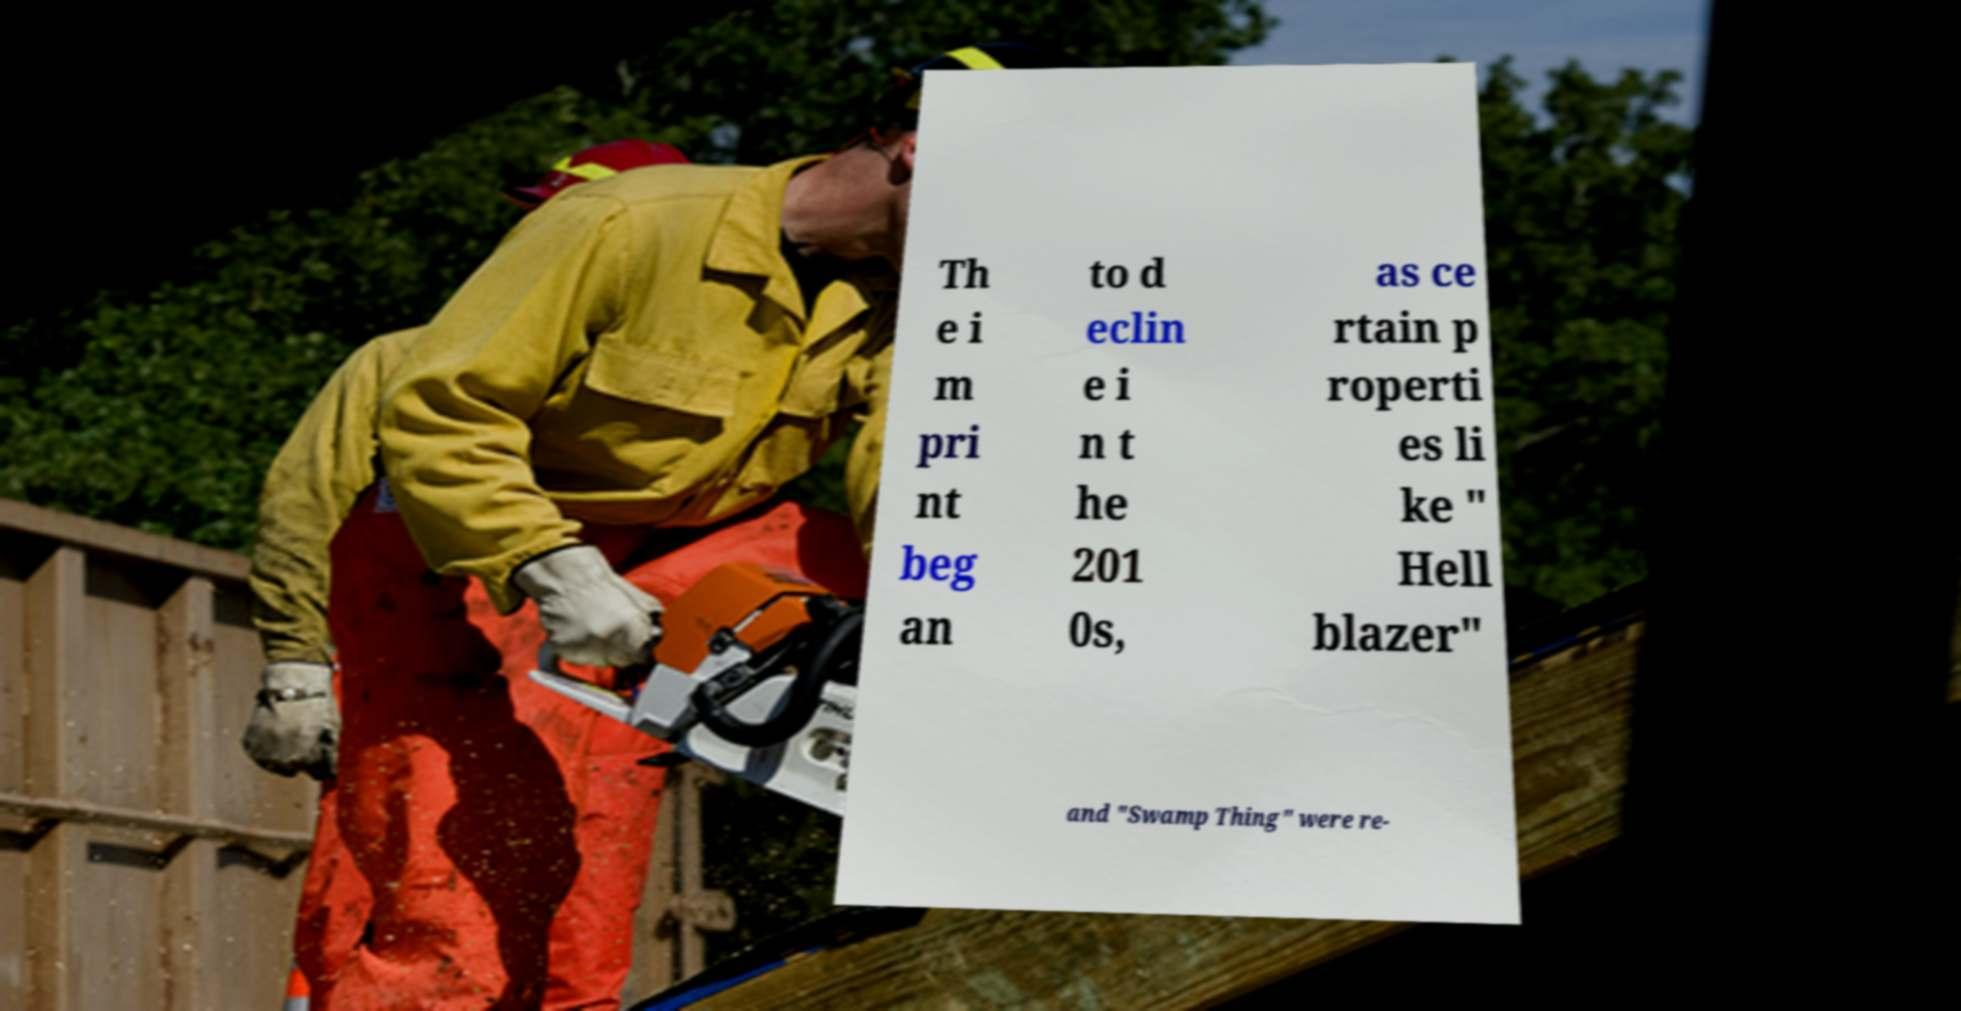Please identify and transcribe the text found in this image. Th e i m pri nt beg an to d eclin e i n t he 201 0s, as ce rtain p roperti es li ke " Hell blazer" and "Swamp Thing" were re- 